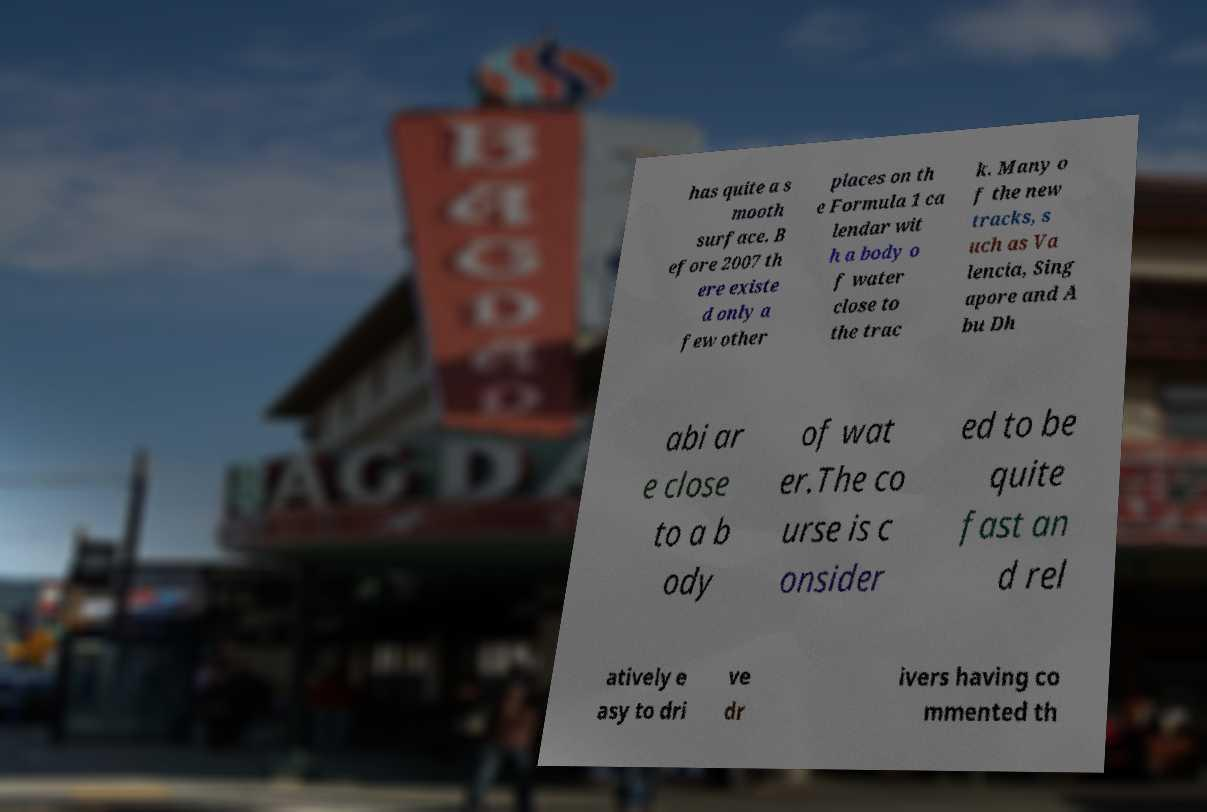Please identify and transcribe the text found in this image. has quite a s mooth surface. B efore 2007 th ere existe d only a few other places on th e Formula 1 ca lendar wit h a body o f water close to the trac k. Many o f the new tracks, s uch as Va lencia, Sing apore and A bu Dh abi ar e close to a b ody of wat er.The co urse is c onsider ed to be quite fast an d rel atively e asy to dri ve dr ivers having co mmented th 